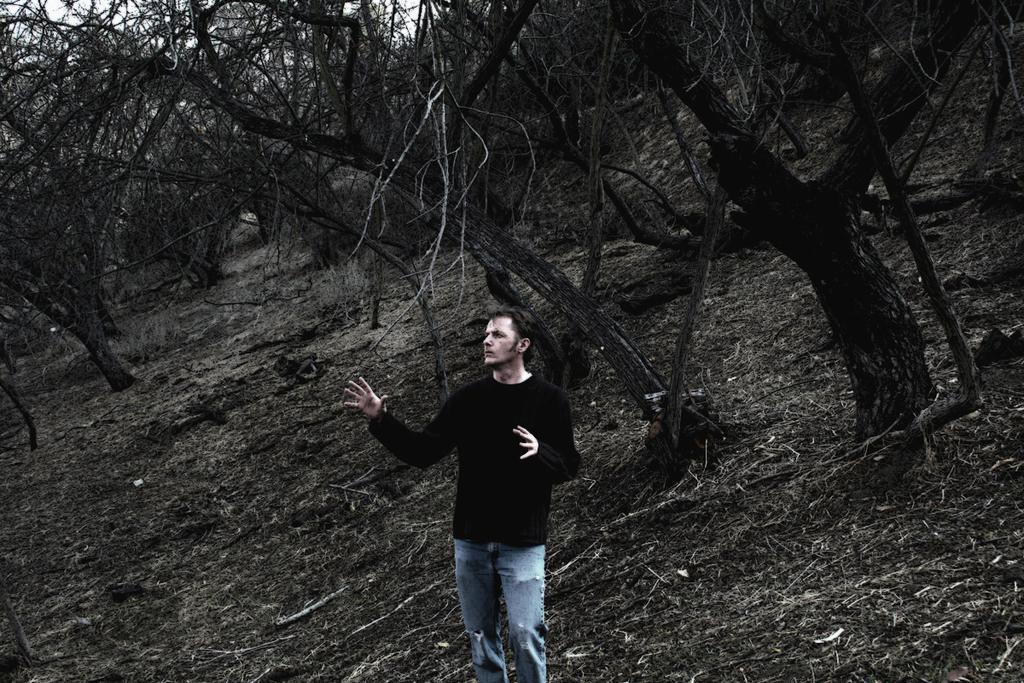What is the main subject of the image? There is a person standing in the image. What is the person wearing on their upper body? The person is wearing a black shirt. What type of pants is the person wearing? The person is wearing jeans. What can be seen in the background of the image? There are trees visible in the background of the image. What type of plant is the person rolling in the image? There is no plant or rolling motion present in the image; it features a person standing and wearing a black shirt and jeans, with trees visible in the background. 